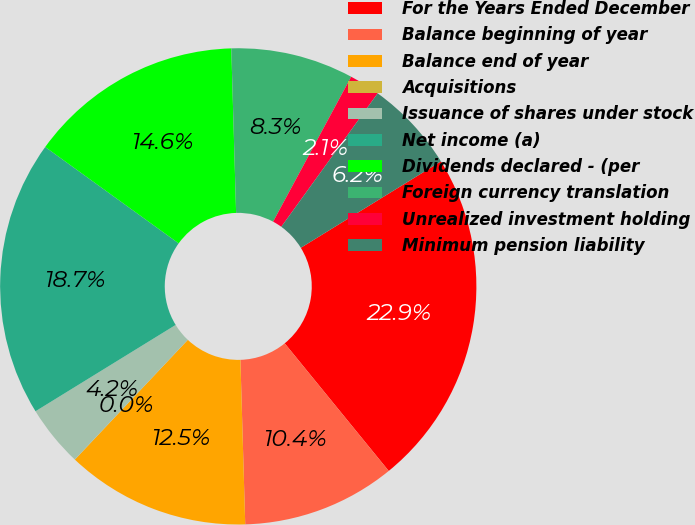Convert chart to OTSL. <chart><loc_0><loc_0><loc_500><loc_500><pie_chart><fcel>For the Years Ended December<fcel>Balance beginning of year<fcel>Balance end of year<fcel>Acquisitions<fcel>Issuance of shares under stock<fcel>Net income (a)<fcel>Dividends declared - (per<fcel>Foreign currency translation<fcel>Unrealized investment holding<fcel>Minimum pension liability<nl><fcel>22.91%<fcel>10.42%<fcel>12.5%<fcel>0.01%<fcel>4.17%<fcel>18.74%<fcel>14.58%<fcel>8.33%<fcel>2.09%<fcel>6.25%<nl></chart> 